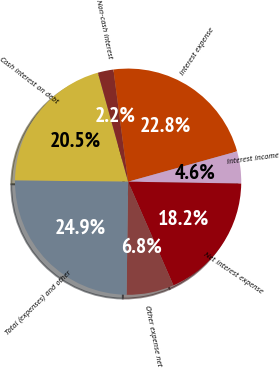<chart> <loc_0><loc_0><loc_500><loc_500><pie_chart><fcel>Cash interest on debt<fcel>Non-cash interest<fcel>Interest expense<fcel>Interest income<fcel>Net interest expense<fcel>Other expense net<fcel>Total (expenses) and other<nl><fcel>20.53%<fcel>2.23%<fcel>22.76%<fcel>4.58%<fcel>18.18%<fcel>6.78%<fcel>24.95%<nl></chart> 